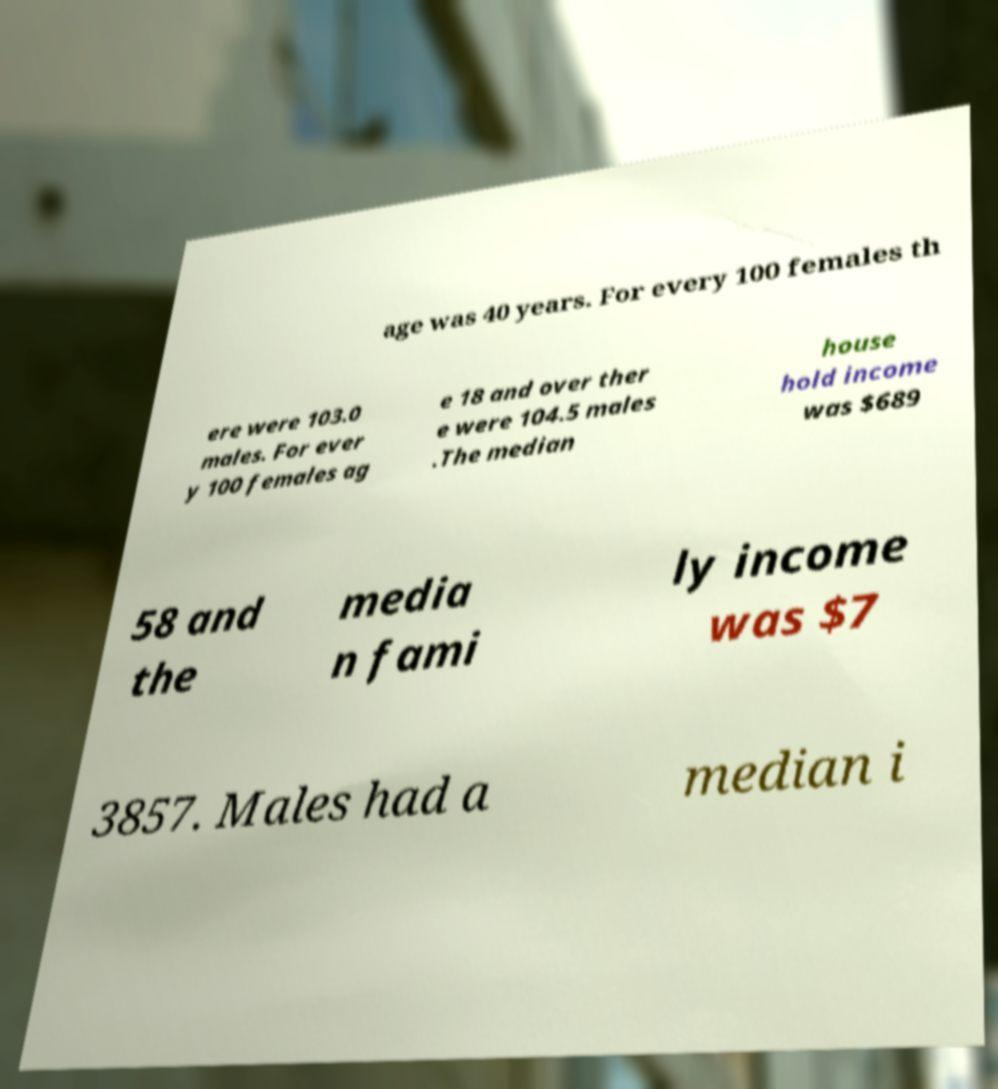Please identify and transcribe the text found in this image. age was 40 years. For every 100 females th ere were 103.0 males. For ever y 100 females ag e 18 and over ther e were 104.5 males .The median house hold income was $689 58 and the media n fami ly income was $7 3857. Males had a median i 